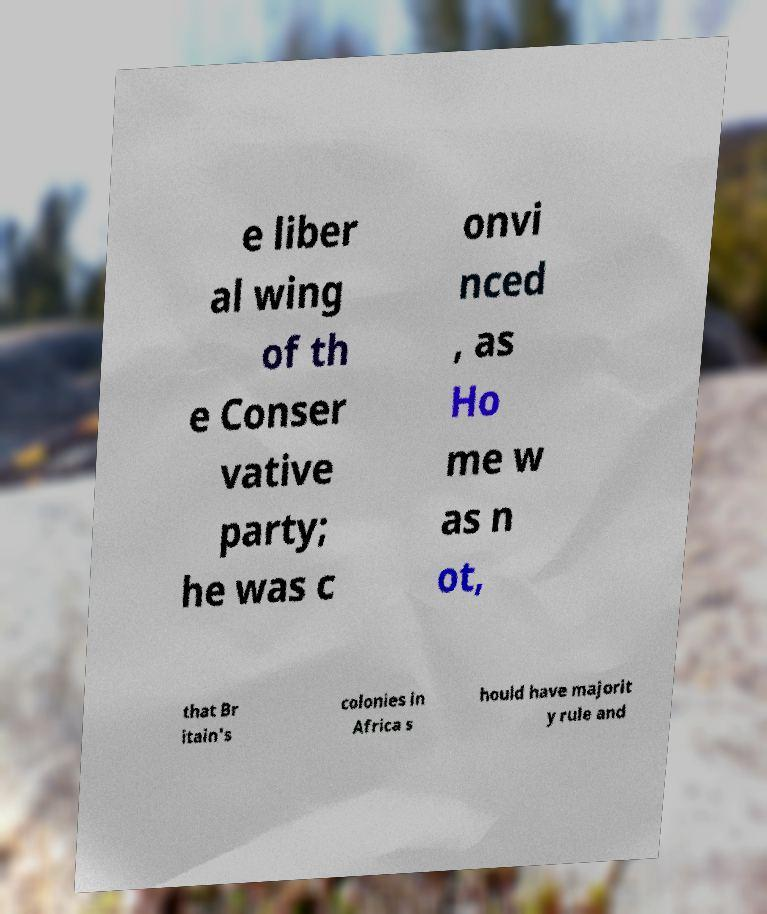I need the written content from this picture converted into text. Can you do that? e liber al wing of th e Conser vative party; he was c onvi nced , as Ho me w as n ot, that Br itain's colonies in Africa s hould have majorit y rule and 